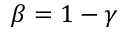Convert formula to latex. <formula><loc_0><loc_0><loc_500><loc_500>\beta = 1 - \gamma</formula> 